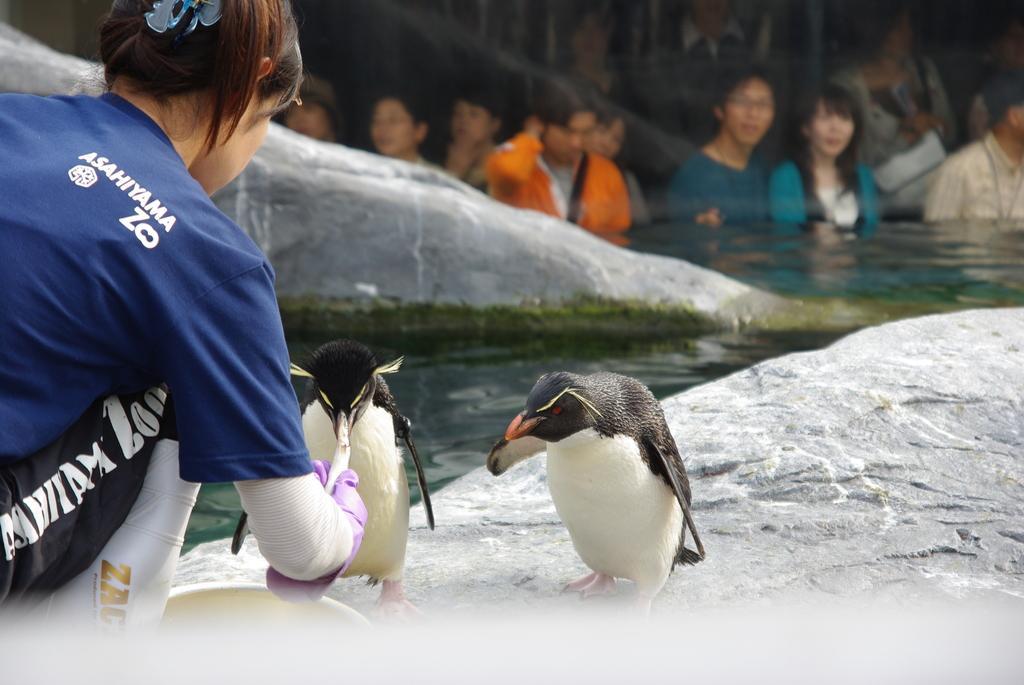Could you give a brief overview of what you see in this image? A woman is feeding penguins in a zoo enclosure. There are some people watching them from a distance. 